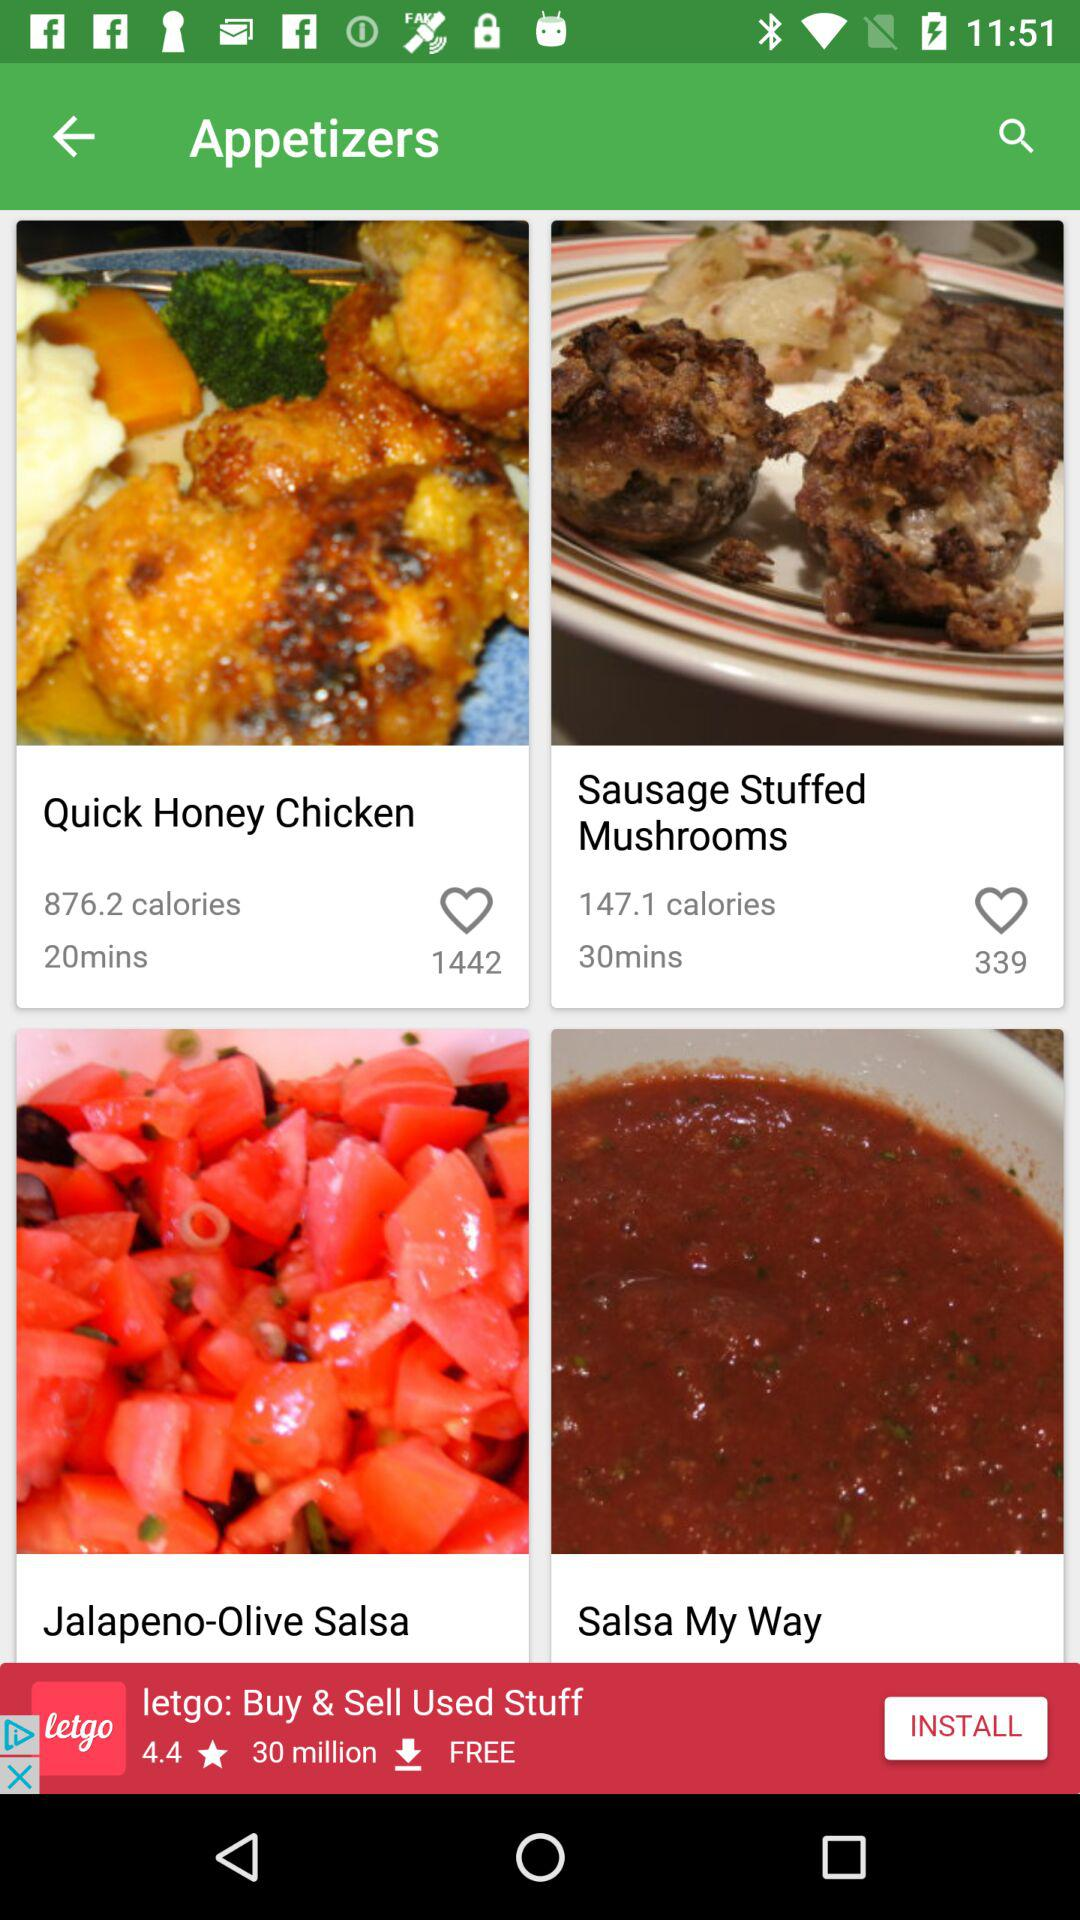How much time is taken to prepare "Sausage Stuffed Mushrooms"? The time taken is 30 minutes. 